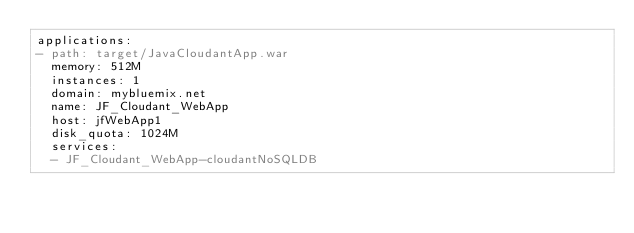Convert code to text. <code><loc_0><loc_0><loc_500><loc_500><_YAML_>applications:
- path: target/JavaCloudantApp.war
  memory: 512M
  instances: 1
  domain: mybluemix.net
  name: JF_Cloudant_WebApp
  host: jfWebApp1
  disk_quota: 1024M
  services:
  - JF_Cloudant_WebApp-cloudantNoSQLDB
</code> 